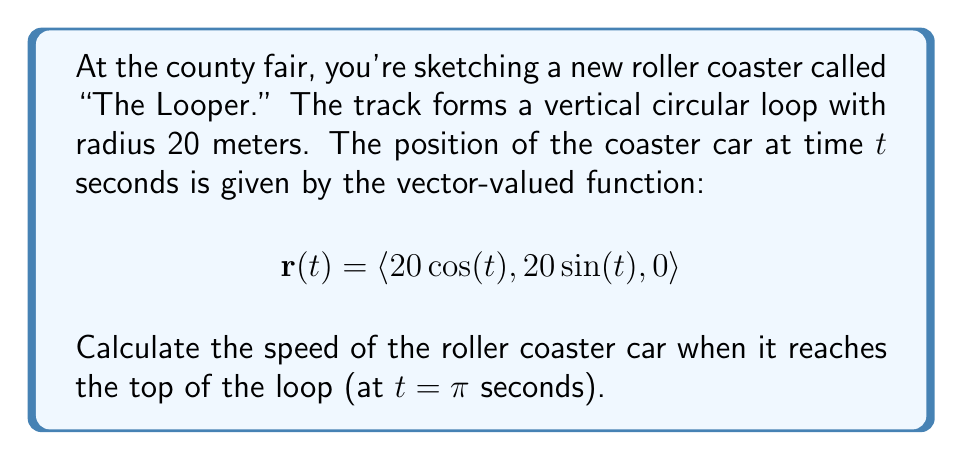Provide a solution to this math problem. To solve this problem, we'll follow these steps:

1) The velocity vector is the derivative of the position vector with respect to time:
   $$\mathbf{v}(t) = \frac{d\mathbf{r}}{dt} = \langle -20\sin(t), 20\cos(t), 0 \rangle$$

2) The speed is the magnitude of the velocity vector:
   $$\text{speed} = |\mathbf{v}(t)| = \sqrt{(-20\sin(t))^2 + (20\cos(t))^2 + 0^2}$$

3) Simplify:
   $$\text{speed} = \sqrt{400\sin^2(t) + 400\cos^2(t)} = \sqrt{400(\sin^2(t) + \cos^2(t))}$$

4) Recall the trigonometric identity $\sin^2(t) + \cos^2(t) = 1$:
   $$\text{speed} = \sqrt{400 \cdot 1} = \sqrt{400} = 20$$

5) This shows that the speed is constant at 20 m/s, regardless of $t$.

6) Therefore, at the top of the loop ($t = \pi$), the speed is also 20 m/s.

This constant speed is a characteristic of circular motion with constant angular velocity, which is the case for this idealized roller coaster loop.
Answer: The speed of the roller coaster car at the top of the loop is 20 m/s. 